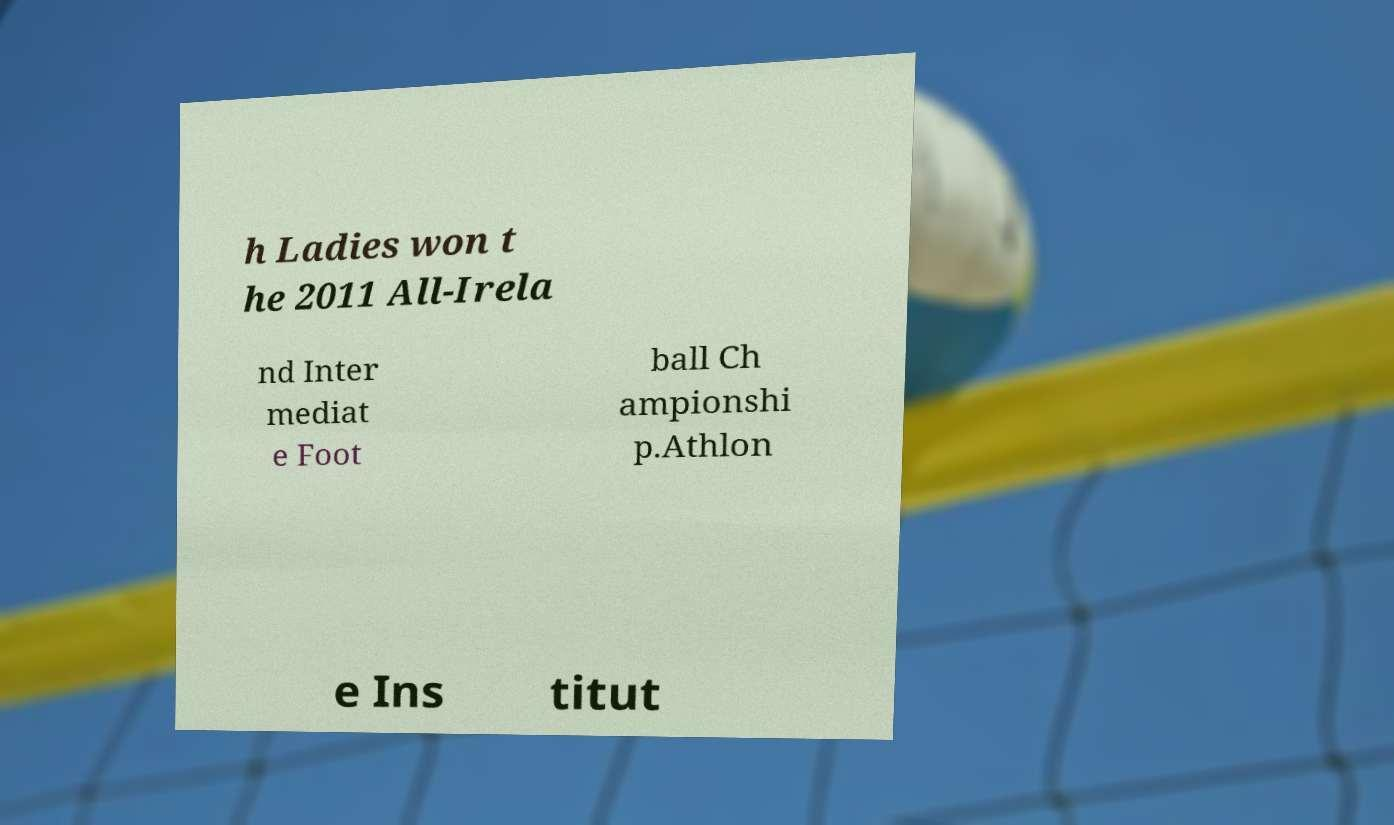For documentation purposes, I need the text within this image transcribed. Could you provide that? h Ladies won t he 2011 All-Irela nd Inter mediat e Foot ball Ch ampionshi p.Athlon e Ins titut 